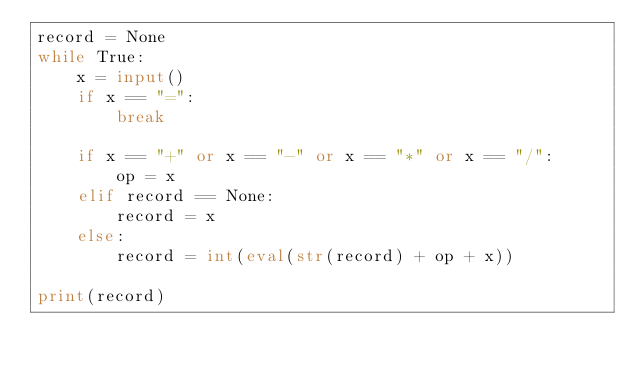Convert code to text. <code><loc_0><loc_0><loc_500><loc_500><_Python_>record = None
while True:
    x = input()
    if x == "=":
        break

    if x == "+" or x == "-" or x == "*" or x == "/":
        op = x
    elif record == None:
        record = x
    else:
        record = int(eval(str(record) + op + x))

print(record)

</code> 